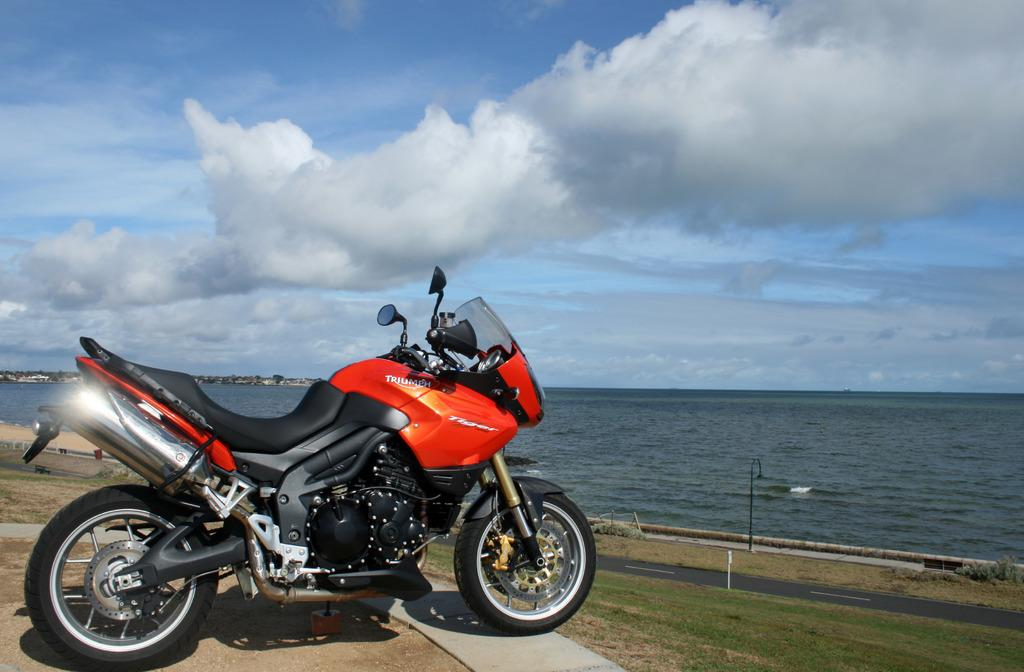What is the main object in the image? There is a bike in the image. Where is the bike located? The bike is parked on a surface. What type of vegetation is in front of the bike? There is grass in front of the bike. What is visible in front of the bike? There is a road in front of the bike. What can be seen in the background of the image? Water is visible in the background of the image. What type of bun is being used as a neck support for the bike in the image? There is no bun or neck support present in the image; it features a bike parked on a surface with grass, a road, and water visible in the background. 